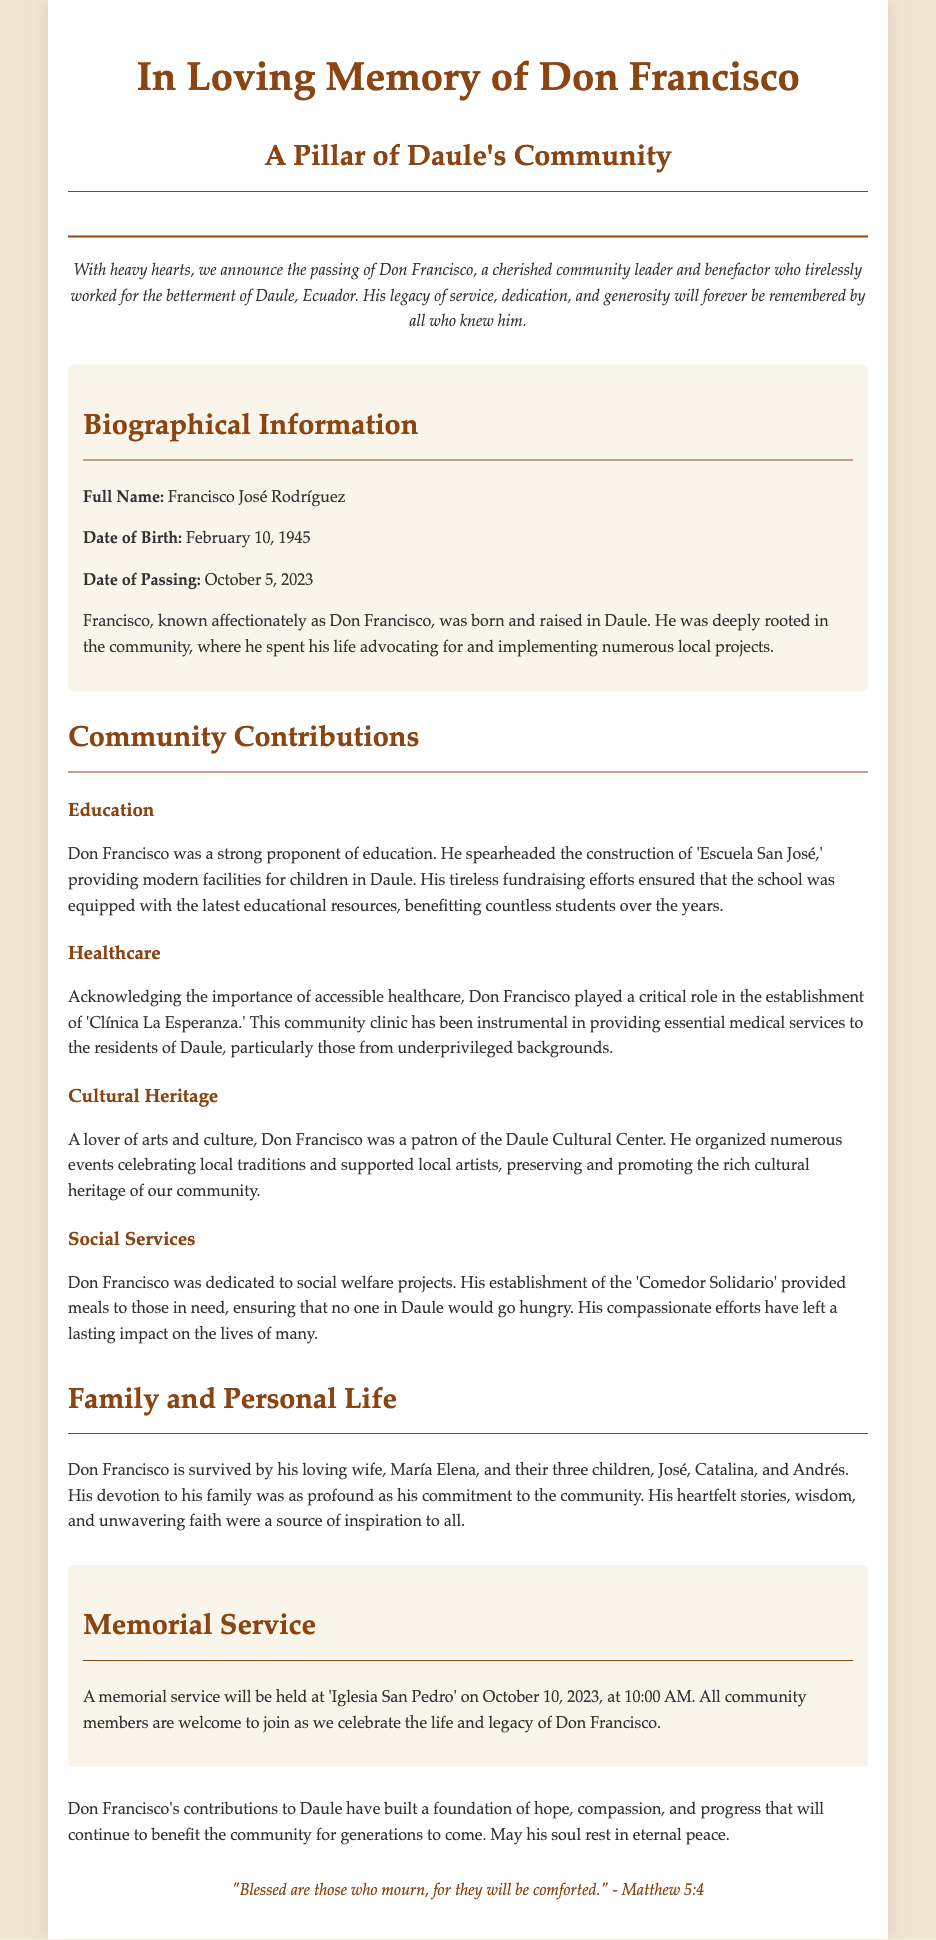What was Don Francisco's full name? The document explicitly mentions his full name as Francisco José Rodríguez.
Answer: Francisco José Rodríguez When was Don Francisco born? The date of birth provided in the document is February 10, 1945.
Answer: February 10, 1945 What significant project did Don Francisco contribute to for education? The document states that he spearheaded the construction of 'Escuela San José.'
Answer: Escuela San José What service did Don Francisco provide related to healthcare? According to the document, he played a critical role in the establishment of 'Clínica La Esperanza.'
Answer: Clínica La Esperanza How many children did Don Francisco have? The document mentions that he had three children.
Answer: Three What was the purpose of 'Comedor Solidario' established by Don Francisco? The document describes it as providing meals to those in need in Daule.
Answer: Providing meals Where will the memorial service be held? The document specifies that the memorial service will be held at 'Iglesia San Pedro.'
Answer: Iglesia San Pedro What is one of the cultural contributions made by Don Francisco? The document states he was a patron of the Daule Cultural Center, organizing events.
Answer: Daule Cultural Center What quote is included in the footer of the document? The footer contains a quote from Matthew 5:4 about mourning and comfort.
Answer: "Blessed are those who mourn, for they will be comforted." 